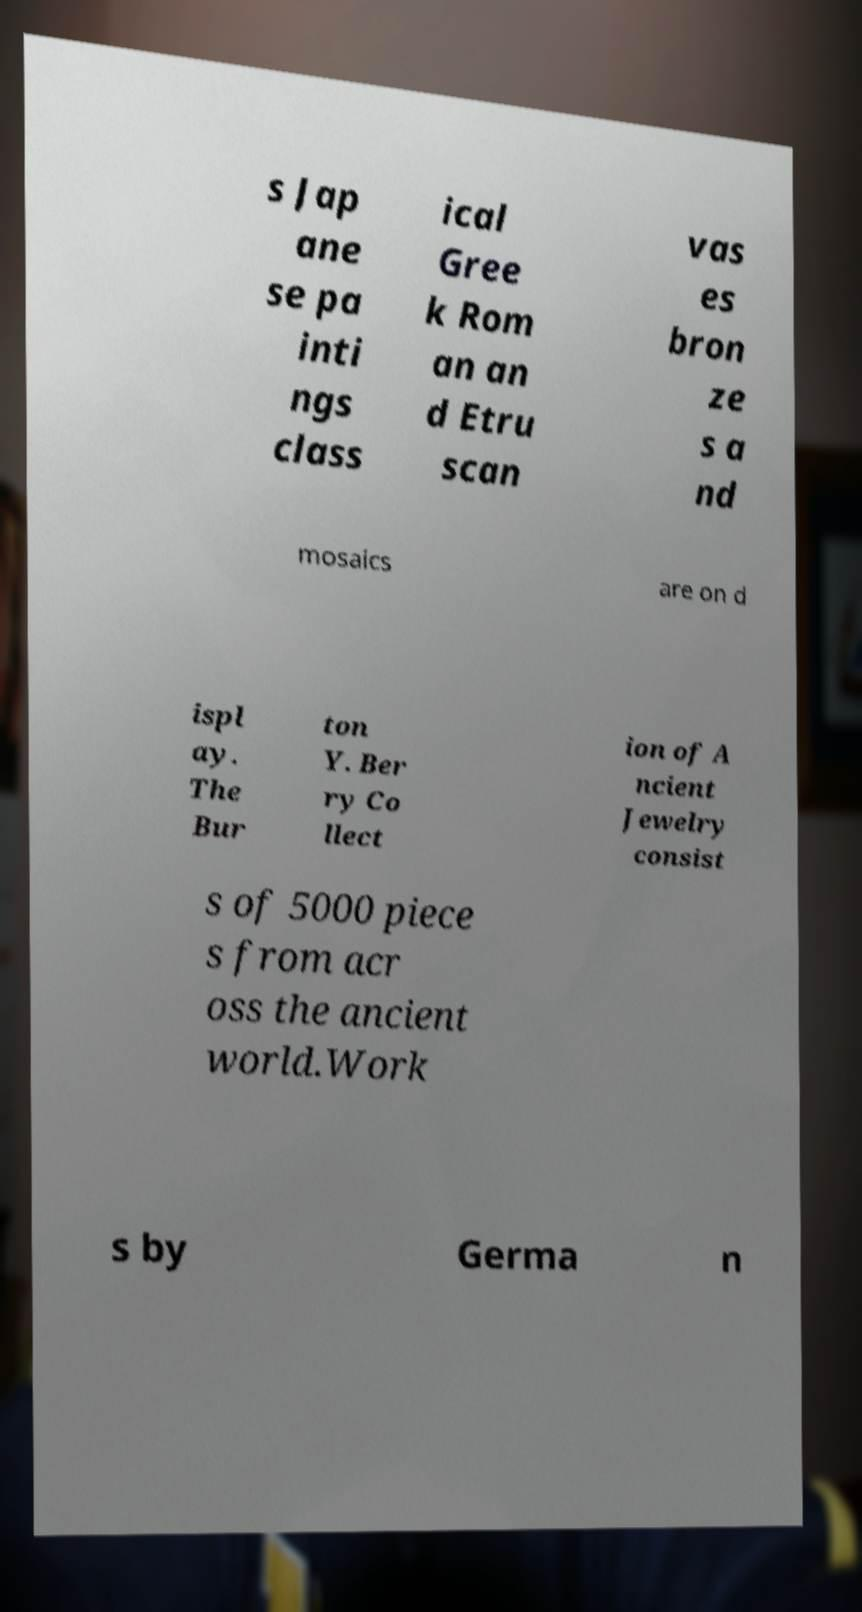Can you read and provide the text displayed in the image?This photo seems to have some interesting text. Can you extract and type it out for me? s Jap ane se pa inti ngs class ical Gree k Rom an an d Etru scan vas es bron ze s a nd mosaics are on d ispl ay. The Bur ton Y. Ber ry Co llect ion of A ncient Jewelry consist s of 5000 piece s from acr oss the ancient world.Work s by Germa n 